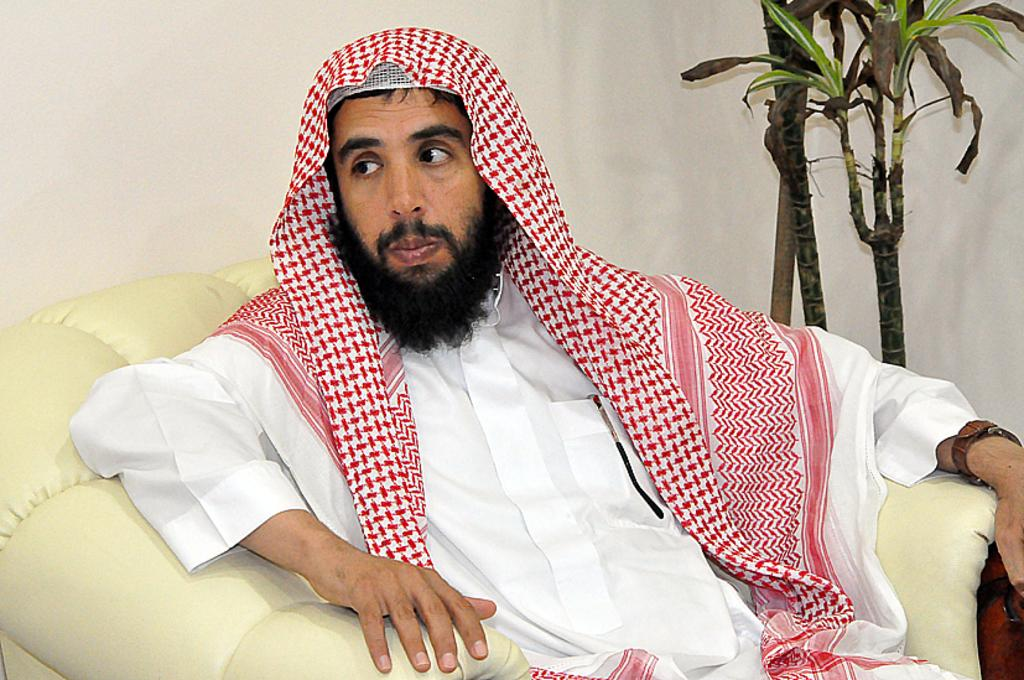Who is the main subject in the foreground of the image? There is a man in the foreground of the image. What is the man wearing? The man is wearing a white dress. What is the man doing in the image? The man is sitting on a sofa. What can be seen in the background of the image? There is a wall and a plant in the background of the image. What type of zinc is being used to play the game in the image? There is no game or zinc present in the image. What color is the cord that the man is holding in the image? There is no cord present in the image; the man is sitting on a sofa and wearing a white dress. 